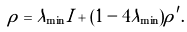<formula> <loc_0><loc_0><loc_500><loc_500>\rho = \lambda _ { \min } I + ( 1 - 4 \lambda _ { \min } ) \rho ^ { \prime } .</formula> 